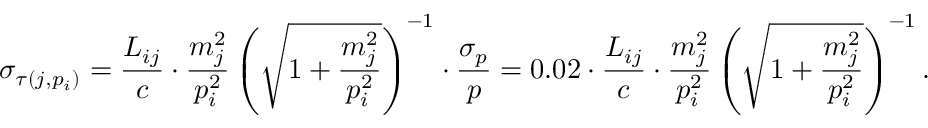<formula> <loc_0><loc_0><loc_500><loc_500>\sigma _ { \tau ( j , p _ { i } ) } = \frac { L _ { i j } } { c } \cdot \frac { m _ { j } ^ { 2 } } { p _ { i } ^ { 2 } } \left ( \sqrt { 1 + \frac { m _ { j } ^ { 2 } } { p _ { i } ^ { 2 } } } \right ) ^ { - 1 } \cdot \frac { \sigma _ { p } } { p } = 0 . 0 2 \cdot \frac { L _ { i j } } { c } \cdot \frac { m _ { j } ^ { 2 } } { p _ { i } ^ { 2 } } \left ( \sqrt { 1 + \frac { m _ { j } ^ { 2 } } { p _ { i } ^ { 2 } } } \right ) ^ { - 1 } .</formula> 